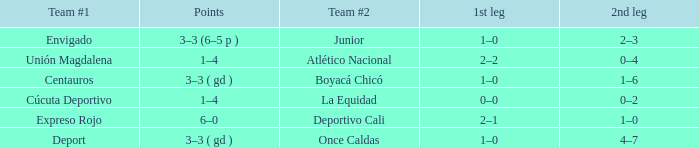What is the 2nd leg for the team #2 junior? 2–3. 